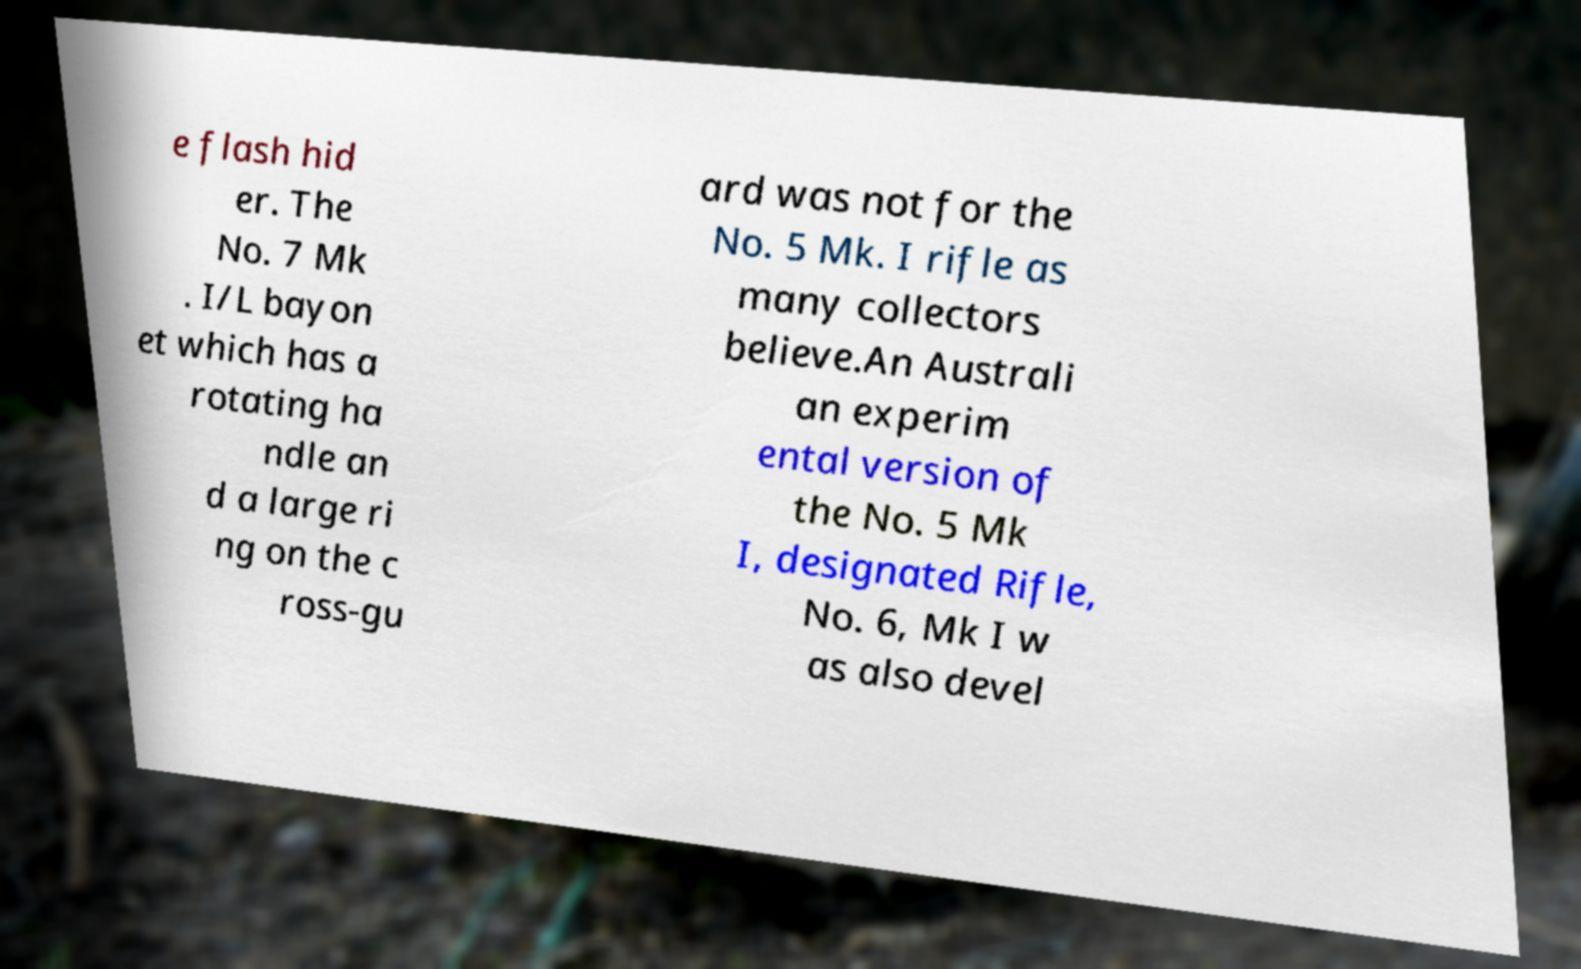Could you extract and type out the text from this image? e flash hid er. The No. 7 Mk . I/L bayon et which has a rotating ha ndle an d a large ri ng on the c ross-gu ard was not for the No. 5 Mk. I rifle as many collectors believe.An Australi an experim ental version of the No. 5 Mk I, designated Rifle, No. 6, Mk I w as also devel 